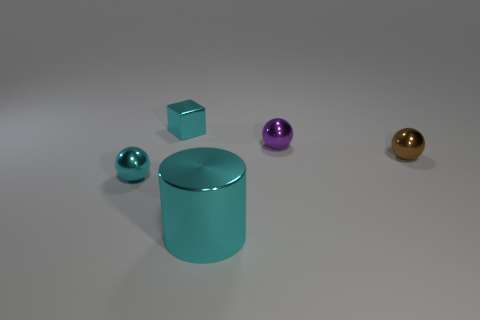Subtract all small brown metal spheres. How many spheres are left? 2 Subtract all purple balls. How many balls are left? 2 Subtract all cylinders. How many objects are left? 4 Subtract 2 balls. How many balls are left? 1 Subtract all green cylinders. How many brown spheres are left? 1 Add 5 tiny purple balls. How many objects exist? 10 Subtract 1 brown balls. How many objects are left? 4 Subtract all yellow balls. Subtract all blue blocks. How many balls are left? 3 Subtract all metal objects. Subtract all big gray things. How many objects are left? 0 Add 1 cyan metallic objects. How many cyan metallic objects are left? 4 